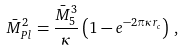Convert formula to latex. <formula><loc_0><loc_0><loc_500><loc_500>\bar { M } _ { P l } ^ { 2 } = \frac { \bar { M } _ { 5 } ^ { 3 } } { \kappa } \left ( 1 - e ^ { - 2 \pi \kappa r _ { c } } \right ) \, ,</formula> 